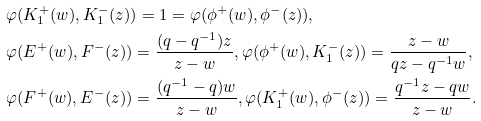<formula> <loc_0><loc_0><loc_500><loc_500>& \varphi ( K _ { 1 } ^ { + } ( w ) , K _ { 1 } ^ { - } ( z ) ) = 1 = \varphi ( \phi ^ { + } ( w ) , \phi ^ { - } ( z ) ) , \\ & \varphi ( E ^ { + } ( w ) , F ^ { - } ( z ) ) = \frac { ( q - q ^ { - 1 } ) z } { z - w } , \varphi ( \phi ^ { + } ( w ) , K _ { 1 } ^ { - } ( z ) ) = \frac { z - w } { q z - q ^ { - 1 } w } , \\ & \varphi ( F ^ { + } ( w ) , E ^ { - } ( z ) ) = \frac { ( q ^ { - 1 } - q ) w } { z - w } , \varphi ( K _ { 1 } ^ { + } ( w ) , \phi ^ { - } ( z ) ) = \frac { q ^ { - 1 } z - q w } { z - w } .</formula> 